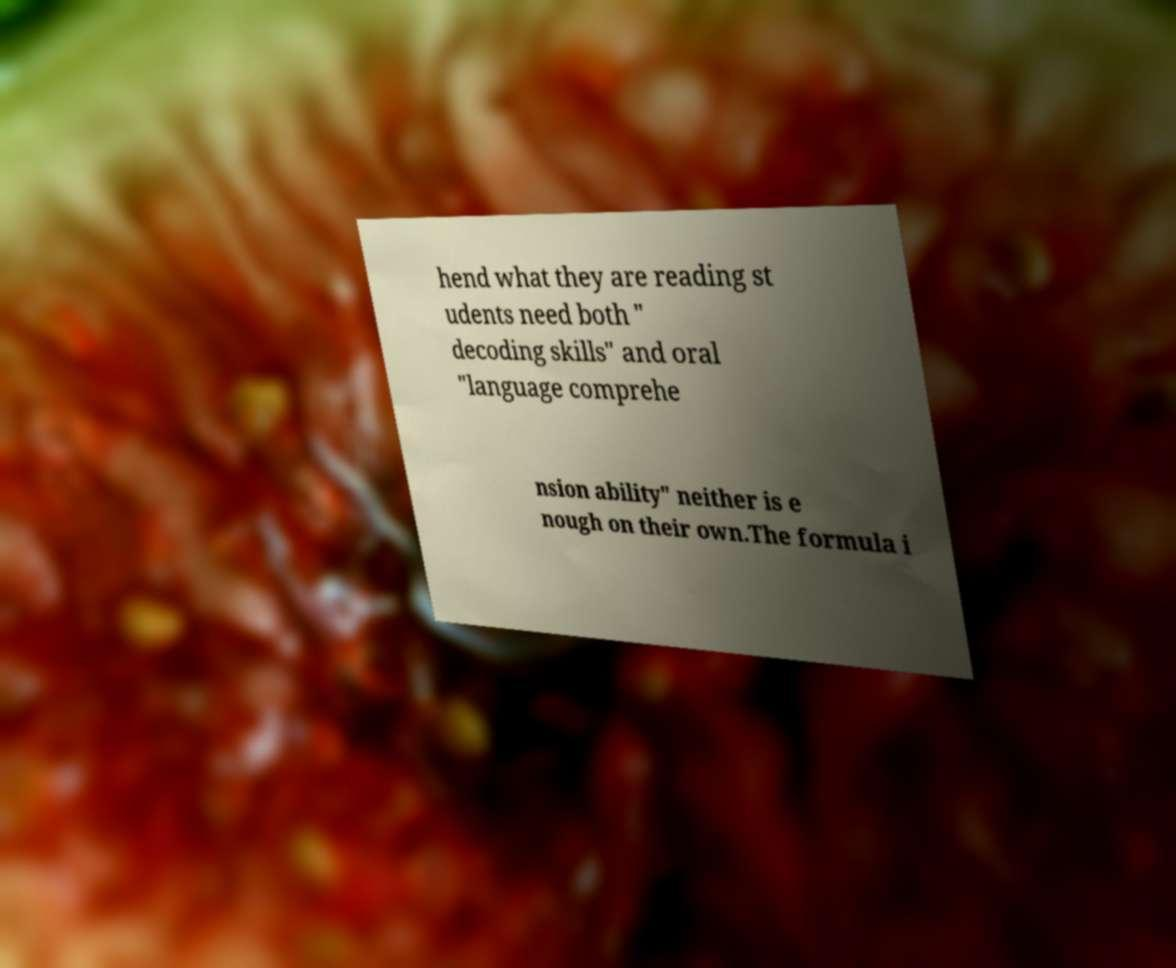What messages or text are displayed in this image? I need them in a readable, typed format. hend what they are reading st udents need both " decoding skills" and oral "language comprehe nsion ability" neither is e nough on their own.The formula i 